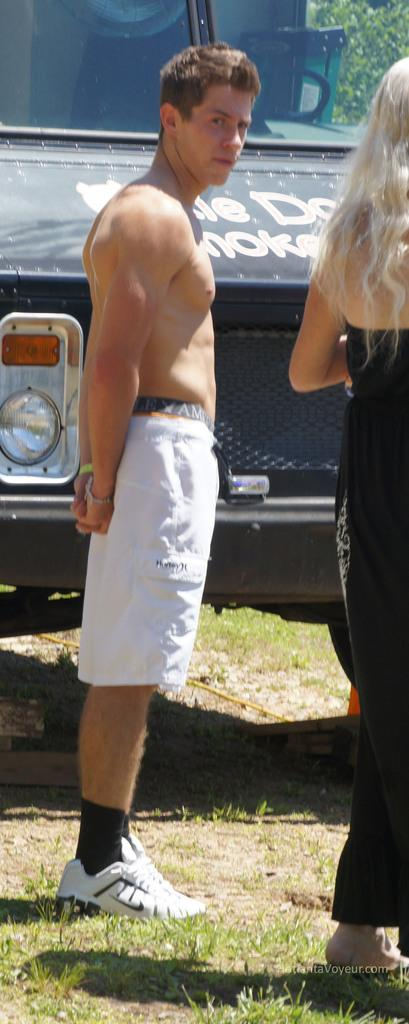How many people are in the image? There is a man and a woman in the image. What are the man and woman doing in the image? The man and woman are standing. What is written or displayed at the bottom of the image? There is text at the bottom of the image. What can be seen in the background of the image? There is a vehicle and a tree in the background of the image. What color of paint is being used on the pipe in the image? There is no pipe or paint present in the image. How does the man's throat look in the image? The image does not show the man's throat, so it cannot be described. 